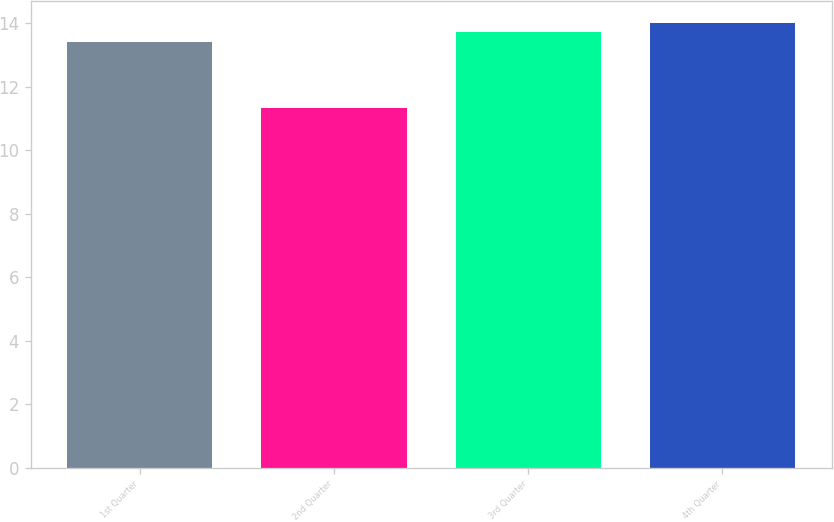<chart> <loc_0><loc_0><loc_500><loc_500><bar_chart><fcel>1st Quarter<fcel>2nd Quarter<fcel>3rd Quarter<fcel>4th Quarter<nl><fcel>13.4<fcel>11.35<fcel>13.74<fcel>14<nl></chart> 